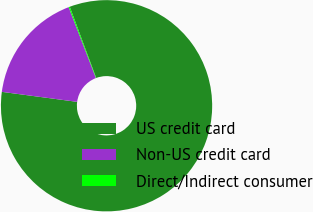<chart> <loc_0><loc_0><loc_500><loc_500><pie_chart><fcel>US credit card<fcel>Non-US credit card<fcel>Direct/Indirect consumer<nl><fcel>82.76%<fcel>17.06%<fcel>0.17%<nl></chart> 